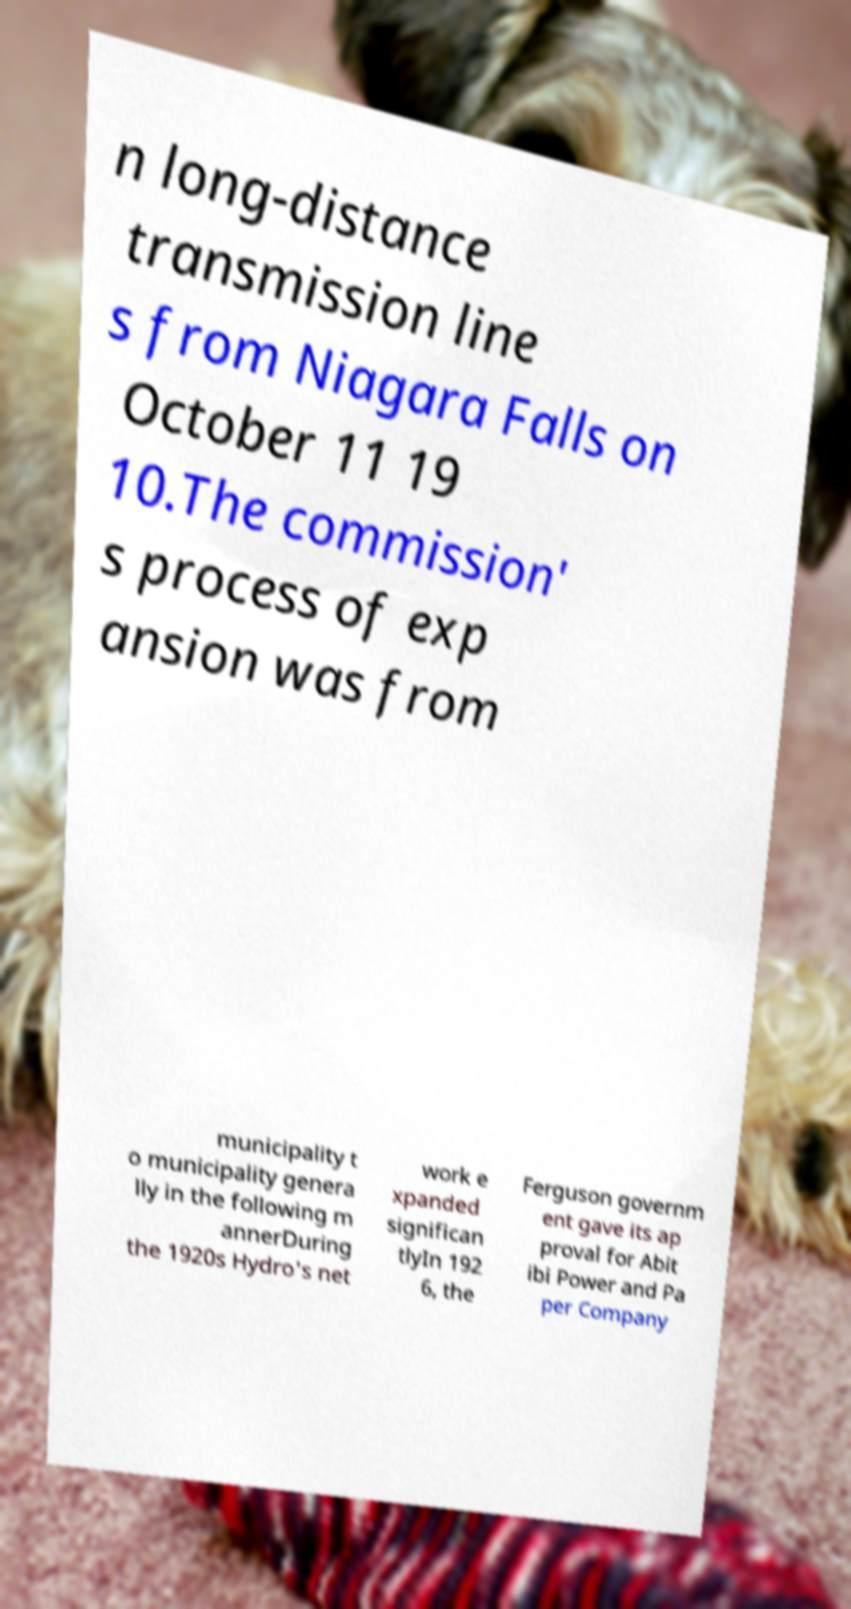Please identify and transcribe the text found in this image. n long-distance transmission line s from Niagara Falls on October 11 19 10.The commission' s process of exp ansion was from municipality t o municipality genera lly in the following m annerDuring the 1920s Hydro's net work e xpanded significan tlyIn 192 6, the Ferguson governm ent gave its ap proval for Abit ibi Power and Pa per Company 